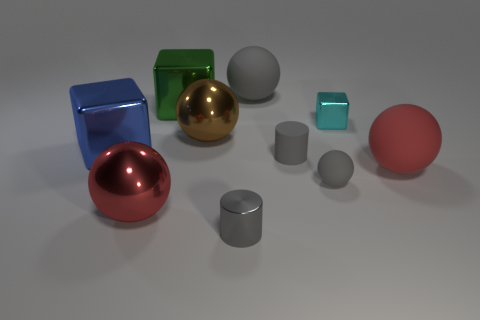There is a green metallic object that is on the left side of the brown thing; is its shape the same as the red rubber object?
Your response must be concise. No. There is a cube that is on the right side of the sphere behind the cyan cube; what number of gray objects are in front of it?
Make the answer very short. 3. What number of objects are either big objects or yellow blocks?
Your answer should be very brief. 6. Is the shape of the large gray object the same as the large blue metallic object left of the small matte cylinder?
Give a very brief answer. No. What is the shape of the red thing that is on the right side of the gray rubber cylinder?
Your answer should be very brief. Sphere. Is the shape of the small gray shiny object the same as the brown thing?
Make the answer very short. No. There is a red matte object that is the same shape as the large brown object; what size is it?
Ensure brevity in your answer.  Large. Does the gray object behind the blue cube have the same size as the small gray metal object?
Offer a terse response. No. How big is the object that is on the right side of the gray matte cylinder and to the left of the tiny cube?
Your response must be concise. Small. There is another small cylinder that is the same color as the tiny matte cylinder; what is its material?
Make the answer very short. Metal. 